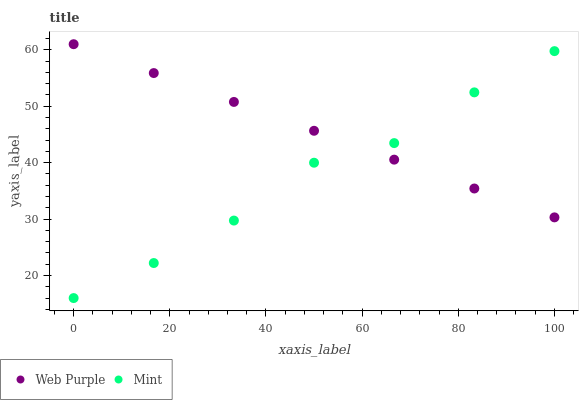Does Mint have the minimum area under the curve?
Answer yes or no. Yes. Does Web Purple have the maximum area under the curve?
Answer yes or no. Yes. Does Mint have the maximum area under the curve?
Answer yes or no. No. Is Web Purple the smoothest?
Answer yes or no. Yes. Is Mint the roughest?
Answer yes or no. Yes. Is Mint the smoothest?
Answer yes or no. No. Does Mint have the lowest value?
Answer yes or no. Yes. Does Web Purple have the highest value?
Answer yes or no. Yes. Does Mint have the highest value?
Answer yes or no. No. Does Mint intersect Web Purple?
Answer yes or no. Yes. Is Mint less than Web Purple?
Answer yes or no. No. Is Mint greater than Web Purple?
Answer yes or no. No. 